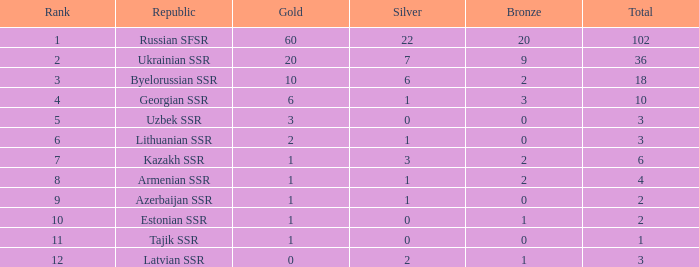What is the mean sum for groups with over 1 gold, rated above 3, and exceeding 3 bronze? None. 